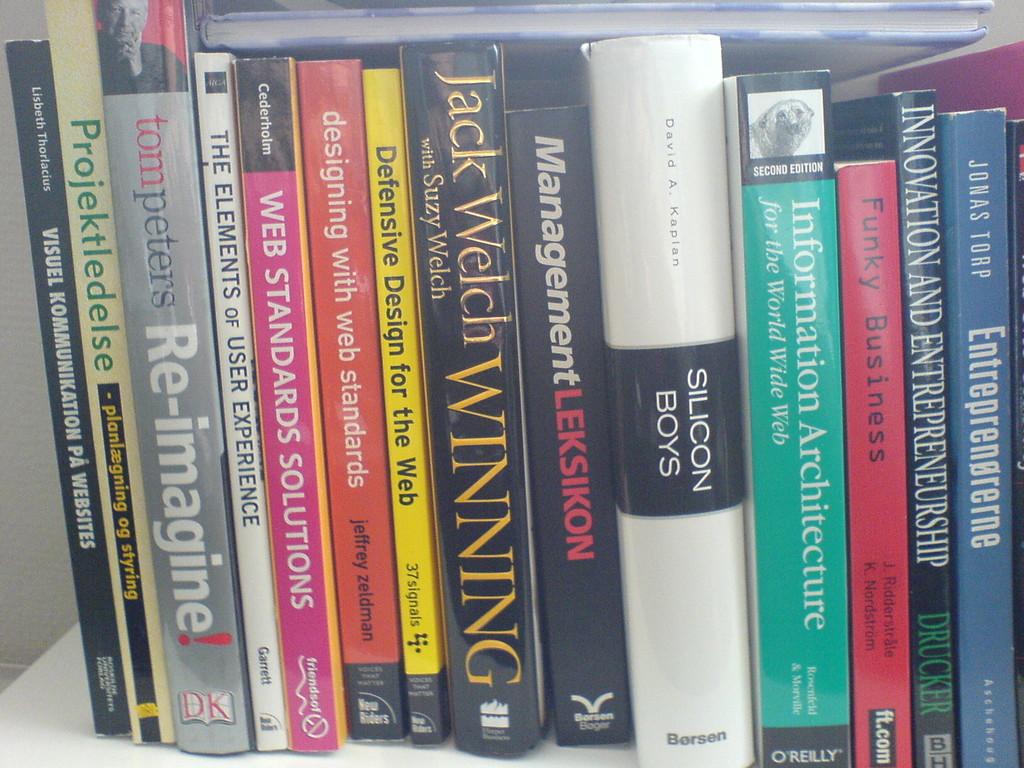What is the title of the book on the far left?
Your answer should be very brief. Visuel kommunikation pa websites. 